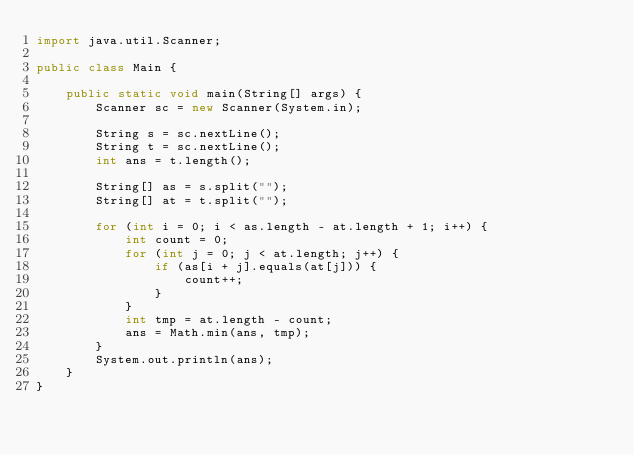<code> <loc_0><loc_0><loc_500><loc_500><_Java_>import java.util.Scanner;

public class Main {

    public static void main(String[] args) {
        Scanner sc = new Scanner(System.in);

        String s = sc.nextLine();
        String t = sc.nextLine();
        int ans = t.length();

        String[] as = s.split("");
        String[] at = t.split("");

        for (int i = 0; i < as.length - at.length + 1; i++) {
            int count = 0;
            for (int j = 0; j < at.length; j++) {
                if (as[i + j].equals(at[j])) {
                    count++;
                }
            }
            int tmp = at.length - count;
            ans = Math.min(ans, tmp);
        }
        System.out.println(ans);
    }
}
</code> 